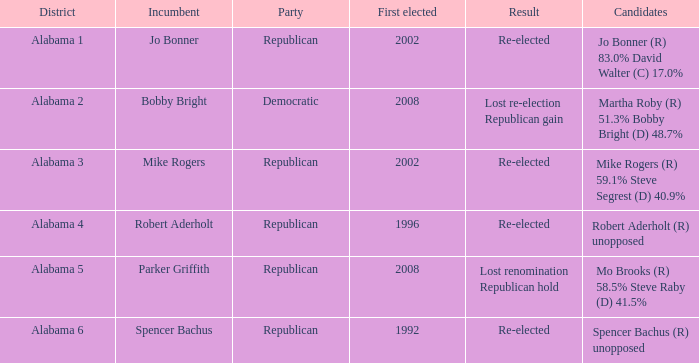Can you provide the consequence of the initial election that took place in 1992? Re-elected. 